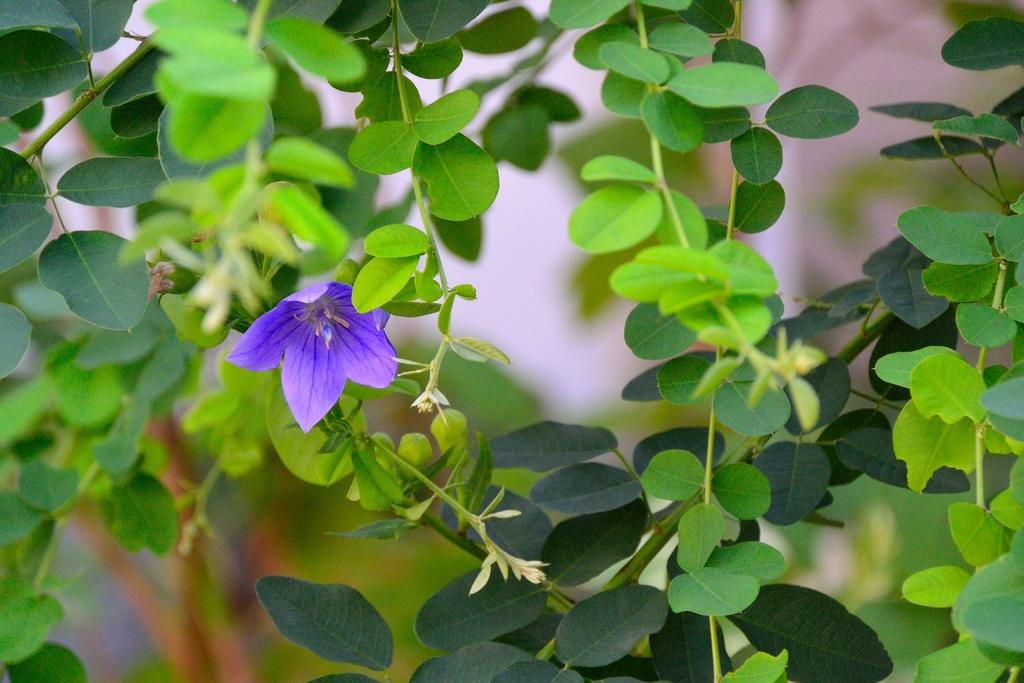What type of plant is visible in the image? There is a flower in the image. Are there any other plants present in the image? Yes, there are plants in the image. Can you describe the background of the image? The background of the image is blurred. What type of cork can be seen in the image? There is no cork present in the image. How many shades of green are visible in the image? The provided facts do not specify the number of shades of green in the image, so it cannot be determined from the information given. 